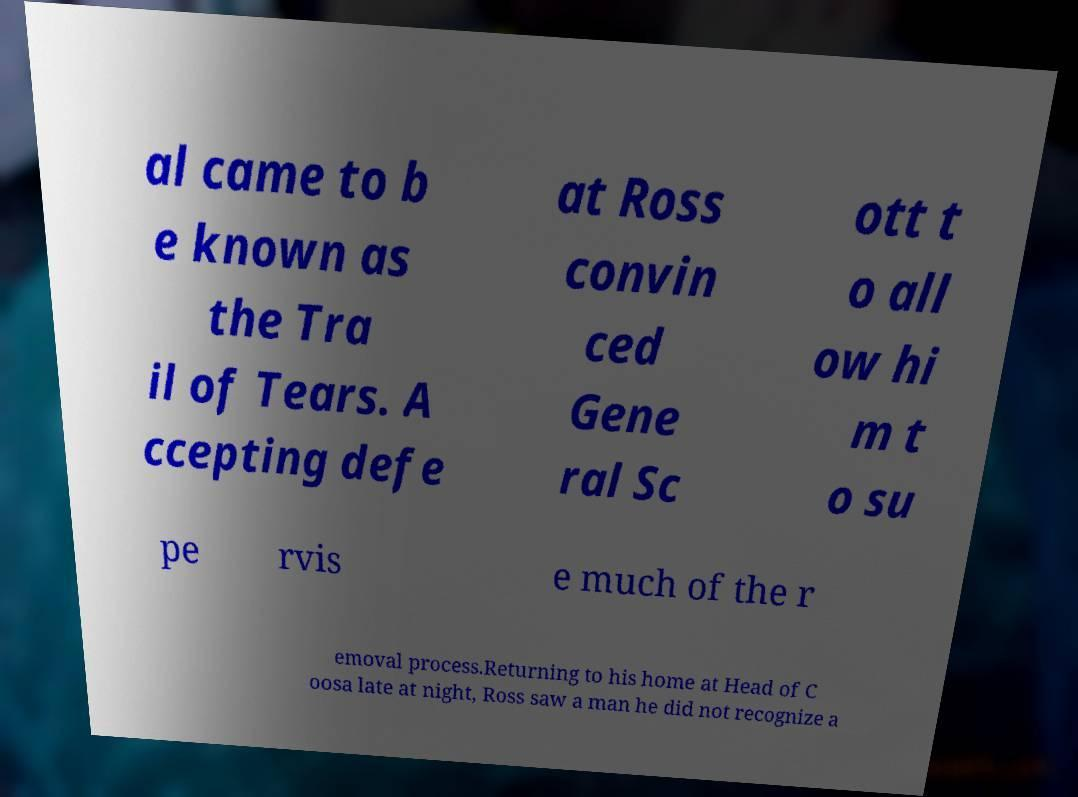Can you read and provide the text displayed in the image?This photo seems to have some interesting text. Can you extract and type it out for me? al came to b e known as the Tra il of Tears. A ccepting defe at Ross convin ced Gene ral Sc ott t o all ow hi m t o su pe rvis e much of the r emoval process.Returning to his home at Head of C oosa late at night, Ross saw a man he did not recognize a 